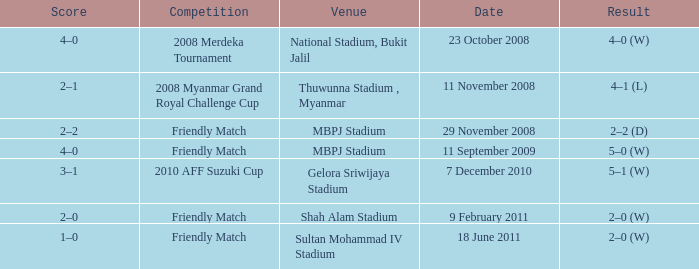What Competition had a Score of 2–0? Friendly Match. 